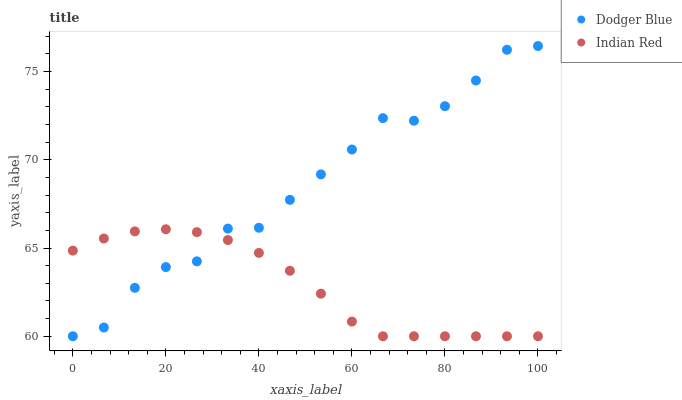Does Indian Red have the minimum area under the curve?
Answer yes or no. Yes. Does Dodger Blue have the maximum area under the curve?
Answer yes or no. Yes. Does Indian Red have the maximum area under the curve?
Answer yes or no. No. Is Indian Red the smoothest?
Answer yes or no. Yes. Is Dodger Blue the roughest?
Answer yes or no. Yes. Is Indian Red the roughest?
Answer yes or no. No. Does Dodger Blue have the lowest value?
Answer yes or no. Yes. Does Dodger Blue have the highest value?
Answer yes or no. Yes. Does Indian Red have the highest value?
Answer yes or no. No. Does Indian Red intersect Dodger Blue?
Answer yes or no. Yes. Is Indian Red less than Dodger Blue?
Answer yes or no. No. Is Indian Red greater than Dodger Blue?
Answer yes or no. No. 